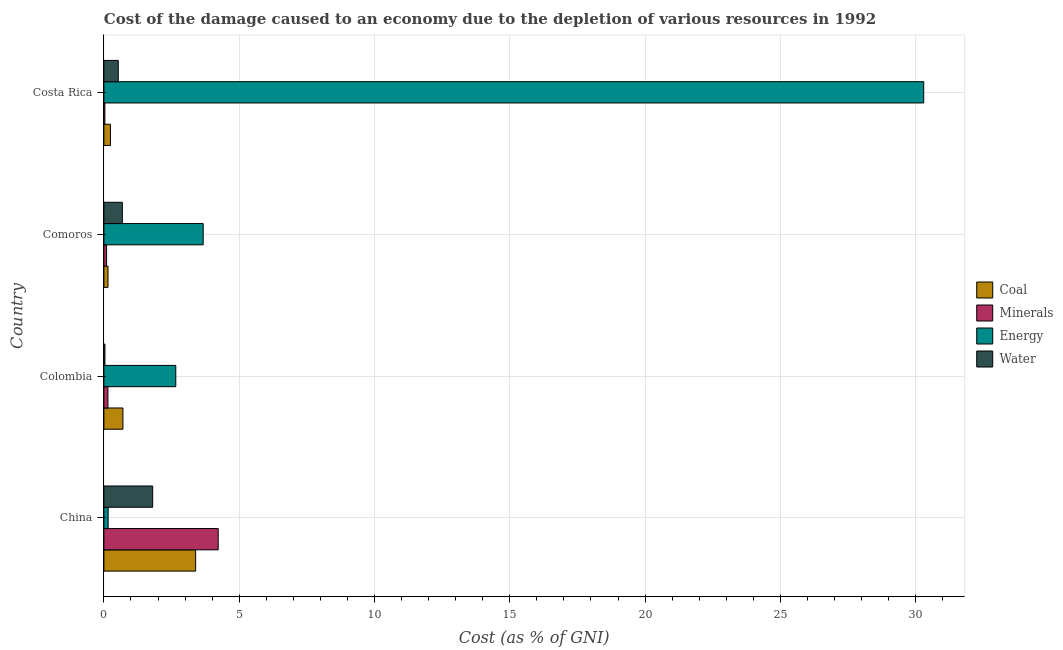How many different coloured bars are there?
Make the answer very short. 4. How many groups of bars are there?
Offer a very short reply. 4. Are the number of bars per tick equal to the number of legend labels?
Your response must be concise. Yes. What is the label of the 4th group of bars from the top?
Keep it short and to the point. China. What is the cost of damage due to depletion of coal in Colombia?
Your answer should be compact. 0.7. Across all countries, what is the maximum cost of damage due to depletion of coal?
Keep it short and to the point. 3.39. Across all countries, what is the minimum cost of damage due to depletion of energy?
Your answer should be very brief. 0.16. In which country was the cost of damage due to depletion of coal maximum?
Ensure brevity in your answer.  China. In which country was the cost of damage due to depletion of energy minimum?
Provide a short and direct response. China. What is the total cost of damage due to depletion of energy in the graph?
Your response must be concise. 36.78. What is the difference between the cost of damage due to depletion of coal in Comoros and that in Costa Rica?
Your answer should be compact. -0.09. What is the difference between the cost of damage due to depletion of water in Costa Rica and the cost of damage due to depletion of energy in Comoros?
Your answer should be very brief. -3.14. What is the average cost of damage due to depletion of coal per country?
Offer a terse response. 1.12. What is the difference between the cost of damage due to depletion of minerals and cost of damage due to depletion of energy in Costa Rica?
Your response must be concise. -30.26. In how many countries, is the cost of damage due to depletion of coal greater than 30 %?
Your answer should be very brief. 0. What is the ratio of the cost of damage due to depletion of energy in Comoros to that in Costa Rica?
Keep it short and to the point. 0.12. What is the difference between the highest and the second highest cost of damage due to depletion of water?
Offer a very short reply. 1.12. What is the difference between the highest and the lowest cost of damage due to depletion of water?
Your answer should be very brief. 1.76. In how many countries, is the cost of damage due to depletion of minerals greater than the average cost of damage due to depletion of minerals taken over all countries?
Provide a succinct answer. 1. Is the sum of the cost of damage due to depletion of coal in China and Colombia greater than the maximum cost of damage due to depletion of minerals across all countries?
Provide a succinct answer. No. What does the 4th bar from the top in Costa Rica represents?
Offer a terse response. Coal. What does the 2nd bar from the bottom in Colombia represents?
Keep it short and to the point. Minerals. Are all the bars in the graph horizontal?
Give a very brief answer. Yes. What is the difference between two consecutive major ticks on the X-axis?
Your answer should be very brief. 5. Does the graph contain any zero values?
Give a very brief answer. No. Where does the legend appear in the graph?
Your response must be concise. Center right. How are the legend labels stacked?
Provide a short and direct response. Vertical. What is the title of the graph?
Ensure brevity in your answer.  Cost of the damage caused to an economy due to the depletion of various resources in 1992 . Does "Greece" appear as one of the legend labels in the graph?
Your response must be concise. No. What is the label or title of the X-axis?
Provide a succinct answer. Cost (as % of GNI). What is the Cost (as % of GNI) of Coal in China?
Your answer should be very brief. 3.39. What is the Cost (as % of GNI) in Minerals in China?
Offer a terse response. 4.22. What is the Cost (as % of GNI) of Energy in China?
Give a very brief answer. 0.16. What is the Cost (as % of GNI) of Water in China?
Your response must be concise. 1.8. What is the Cost (as % of GNI) in Coal in Colombia?
Provide a short and direct response. 0.7. What is the Cost (as % of GNI) of Minerals in Colombia?
Keep it short and to the point. 0.15. What is the Cost (as % of GNI) in Energy in Colombia?
Give a very brief answer. 2.66. What is the Cost (as % of GNI) of Water in Colombia?
Provide a succinct answer. 0.04. What is the Cost (as % of GNI) of Coal in Comoros?
Offer a terse response. 0.15. What is the Cost (as % of GNI) of Minerals in Comoros?
Offer a very short reply. 0.1. What is the Cost (as % of GNI) of Energy in Comoros?
Your answer should be compact. 3.67. What is the Cost (as % of GNI) of Water in Comoros?
Provide a succinct answer. 0.68. What is the Cost (as % of GNI) of Coal in Costa Rica?
Offer a terse response. 0.24. What is the Cost (as % of GNI) of Minerals in Costa Rica?
Provide a succinct answer. 0.04. What is the Cost (as % of GNI) in Energy in Costa Rica?
Your answer should be compact. 30.3. What is the Cost (as % of GNI) of Water in Costa Rica?
Your answer should be very brief. 0.53. Across all countries, what is the maximum Cost (as % of GNI) in Coal?
Offer a very short reply. 3.39. Across all countries, what is the maximum Cost (as % of GNI) of Minerals?
Offer a very short reply. 4.22. Across all countries, what is the maximum Cost (as % of GNI) in Energy?
Your response must be concise. 30.3. Across all countries, what is the maximum Cost (as % of GNI) in Water?
Your response must be concise. 1.8. Across all countries, what is the minimum Cost (as % of GNI) in Coal?
Ensure brevity in your answer.  0.15. Across all countries, what is the minimum Cost (as % of GNI) in Minerals?
Your response must be concise. 0.04. Across all countries, what is the minimum Cost (as % of GNI) of Energy?
Offer a very short reply. 0.16. Across all countries, what is the minimum Cost (as % of GNI) in Water?
Your answer should be very brief. 0.04. What is the total Cost (as % of GNI) in Coal in the graph?
Make the answer very short. 4.49. What is the total Cost (as % of GNI) in Minerals in the graph?
Make the answer very short. 4.51. What is the total Cost (as % of GNI) in Energy in the graph?
Offer a very short reply. 36.78. What is the total Cost (as % of GNI) of Water in the graph?
Make the answer very short. 3.06. What is the difference between the Cost (as % of GNI) of Coal in China and that in Colombia?
Ensure brevity in your answer.  2.69. What is the difference between the Cost (as % of GNI) in Minerals in China and that in Colombia?
Your answer should be very brief. 4.08. What is the difference between the Cost (as % of GNI) in Energy in China and that in Colombia?
Provide a succinct answer. -2.5. What is the difference between the Cost (as % of GNI) in Water in China and that in Colombia?
Offer a very short reply. 1.76. What is the difference between the Cost (as % of GNI) of Coal in China and that in Comoros?
Your response must be concise. 3.24. What is the difference between the Cost (as % of GNI) of Minerals in China and that in Comoros?
Make the answer very short. 4.13. What is the difference between the Cost (as % of GNI) of Energy in China and that in Comoros?
Ensure brevity in your answer.  -3.51. What is the difference between the Cost (as % of GNI) of Water in China and that in Comoros?
Keep it short and to the point. 1.12. What is the difference between the Cost (as % of GNI) in Coal in China and that in Costa Rica?
Ensure brevity in your answer.  3.15. What is the difference between the Cost (as % of GNI) of Minerals in China and that in Costa Rica?
Provide a succinct answer. 4.19. What is the difference between the Cost (as % of GNI) in Energy in China and that in Costa Rica?
Make the answer very short. -30.14. What is the difference between the Cost (as % of GNI) in Water in China and that in Costa Rica?
Your answer should be very brief. 1.27. What is the difference between the Cost (as % of GNI) in Coal in Colombia and that in Comoros?
Your answer should be compact. 0.55. What is the difference between the Cost (as % of GNI) in Minerals in Colombia and that in Comoros?
Ensure brevity in your answer.  0.05. What is the difference between the Cost (as % of GNI) of Energy in Colombia and that in Comoros?
Keep it short and to the point. -1.01. What is the difference between the Cost (as % of GNI) in Water in Colombia and that in Comoros?
Provide a short and direct response. -0.64. What is the difference between the Cost (as % of GNI) in Coal in Colombia and that in Costa Rica?
Offer a very short reply. 0.46. What is the difference between the Cost (as % of GNI) of Minerals in Colombia and that in Costa Rica?
Provide a short and direct response. 0.11. What is the difference between the Cost (as % of GNI) in Energy in Colombia and that in Costa Rica?
Your response must be concise. -27.64. What is the difference between the Cost (as % of GNI) of Water in Colombia and that in Costa Rica?
Offer a terse response. -0.49. What is the difference between the Cost (as % of GNI) in Coal in Comoros and that in Costa Rica?
Offer a very short reply. -0.09. What is the difference between the Cost (as % of GNI) of Minerals in Comoros and that in Costa Rica?
Your response must be concise. 0.06. What is the difference between the Cost (as % of GNI) in Energy in Comoros and that in Costa Rica?
Offer a terse response. -26.63. What is the difference between the Cost (as % of GNI) in Water in Comoros and that in Costa Rica?
Provide a short and direct response. 0.15. What is the difference between the Cost (as % of GNI) of Coal in China and the Cost (as % of GNI) of Minerals in Colombia?
Provide a succinct answer. 3.24. What is the difference between the Cost (as % of GNI) of Coal in China and the Cost (as % of GNI) of Energy in Colombia?
Offer a very short reply. 0.73. What is the difference between the Cost (as % of GNI) in Coal in China and the Cost (as % of GNI) in Water in Colombia?
Your answer should be very brief. 3.35. What is the difference between the Cost (as % of GNI) of Minerals in China and the Cost (as % of GNI) of Energy in Colombia?
Offer a terse response. 1.57. What is the difference between the Cost (as % of GNI) in Minerals in China and the Cost (as % of GNI) in Water in Colombia?
Ensure brevity in your answer.  4.19. What is the difference between the Cost (as % of GNI) in Energy in China and the Cost (as % of GNI) in Water in Colombia?
Your answer should be compact. 0.12. What is the difference between the Cost (as % of GNI) in Coal in China and the Cost (as % of GNI) in Minerals in Comoros?
Offer a very short reply. 3.29. What is the difference between the Cost (as % of GNI) of Coal in China and the Cost (as % of GNI) of Energy in Comoros?
Your answer should be compact. -0.28. What is the difference between the Cost (as % of GNI) of Coal in China and the Cost (as % of GNI) of Water in Comoros?
Keep it short and to the point. 2.71. What is the difference between the Cost (as % of GNI) of Minerals in China and the Cost (as % of GNI) of Energy in Comoros?
Your response must be concise. 0.55. What is the difference between the Cost (as % of GNI) of Minerals in China and the Cost (as % of GNI) of Water in Comoros?
Provide a short and direct response. 3.54. What is the difference between the Cost (as % of GNI) in Energy in China and the Cost (as % of GNI) in Water in Comoros?
Provide a succinct answer. -0.52. What is the difference between the Cost (as % of GNI) in Coal in China and the Cost (as % of GNI) in Minerals in Costa Rica?
Your answer should be very brief. 3.35. What is the difference between the Cost (as % of GNI) of Coal in China and the Cost (as % of GNI) of Energy in Costa Rica?
Ensure brevity in your answer.  -26.91. What is the difference between the Cost (as % of GNI) in Coal in China and the Cost (as % of GNI) in Water in Costa Rica?
Make the answer very short. 2.86. What is the difference between the Cost (as % of GNI) in Minerals in China and the Cost (as % of GNI) in Energy in Costa Rica?
Your answer should be very brief. -26.07. What is the difference between the Cost (as % of GNI) in Minerals in China and the Cost (as % of GNI) in Water in Costa Rica?
Your response must be concise. 3.69. What is the difference between the Cost (as % of GNI) in Energy in China and the Cost (as % of GNI) in Water in Costa Rica?
Provide a succinct answer. -0.38. What is the difference between the Cost (as % of GNI) of Coal in Colombia and the Cost (as % of GNI) of Minerals in Comoros?
Your answer should be compact. 0.6. What is the difference between the Cost (as % of GNI) in Coal in Colombia and the Cost (as % of GNI) in Energy in Comoros?
Ensure brevity in your answer.  -2.97. What is the difference between the Cost (as % of GNI) of Coal in Colombia and the Cost (as % of GNI) of Water in Comoros?
Your response must be concise. 0.02. What is the difference between the Cost (as % of GNI) in Minerals in Colombia and the Cost (as % of GNI) in Energy in Comoros?
Keep it short and to the point. -3.52. What is the difference between the Cost (as % of GNI) in Minerals in Colombia and the Cost (as % of GNI) in Water in Comoros?
Your answer should be very brief. -0.53. What is the difference between the Cost (as % of GNI) of Energy in Colombia and the Cost (as % of GNI) of Water in Comoros?
Ensure brevity in your answer.  1.98. What is the difference between the Cost (as % of GNI) of Coal in Colombia and the Cost (as % of GNI) of Minerals in Costa Rica?
Your response must be concise. 0.67. What is the difference between the Cost (as % of GNI) of Coal in Colombia and the Cost (as % of GNI) of Energy in Costa Rica?
Provide a succinct answer. -29.6. What is the difference between the Cost (as % of GNI) in Coal in Colombia and the Cost (as % of GNI) in Water in Costa Rica?
Ensure brevity in your answer.  0.17. What is the difference between the Cost (as % of GNI) of Minerals in Colombia and the Cost (as % of GNI) of Energy in Costa Rica?
Provide a short and direct response. -30.15. What is the difference between the Cost (as % of GNI) of Minerals in Colombia and the Cost (as % of GNI) of Water in Costa Rica?
Offer a terse response. -0.38. What is the difference between the Cost (as % of GNI) in Energy in Colombia and the Cost (as % of GNI) in Water in Costa Rica?
Your answer should be compact. 2.12. What is the difference between the Cost (as % of GNI) of Coal in Comoros and the Cost (as % of GNI) of Minerals in Costa Rica?
Ensure brevity in your answer.  0.12. What is the difference between the Cost (as % of GNI) in Coal in Comoros and the Cost (as % of GNI) in Energy in Costa Rica?
Give a very brief answer. -30.15. What is the difference between the Cost (as % of GNI) of Coal in Comoros and the Cost (as % of GNI) of Water in Costa Rica?
Keep it short and to the point. -0.38. What is the difference between the Cost (as % of GNI) of Minerals in Comoros and the Cost (as % of GNI) of Energy in Costa Rica?
Your response must be concise. -30.2. What is the difference between the Cost (as % of GNI) in Minerals in Comoros and the Cost (as % of GNI) in Water in Costa Rica?
Your response must be concise. -0.43. What is the difference between the Cost (as % of GNI) in Energy in Comoros and the Cost (as % of GNI) in Water in Costa Rica?
Your response must be concise. 3.14. What is the average Cost (as % of GNI) of Coal per country?
Give a very brief answer. 1.12. What is the average Cost (as % of GNI) of Minerals per country?
Your answer should be very brief. 1.13. What is the average Cost (as % of GNI) of Energy per country?
Ensure brevity in your answer.  9.2. What is the average Cost (as % of GNI) of Water per country?
Give a very brief answer. 0.76. What is the difference between the Cost (as % of GNI) in Coal and Cost (as % of GNI) in Minerals in China?
Offer a terse response. -0.83. What is the difference between the Cost (as % of GNI) of Coal and Cost (as % of GNI) of Energy in China?
Your answer should be compact. 3.23. What is the difference between the Cost (as % of GNI) in Coal and Cost (as % of GNI) in Water in China?
Your answer should be compact. 1.59. What is the difference between the Cost (as % of GNI) of Minerals and Cost (as % of GNI) of Energy in China?
Offer a very short reply. 4.07. What is the difference between the Cost (as % of GNI) in Minerals and Cost (as % of GNI) in Water in China?
Keep it short and to the point. 2.42. What is the difference between the Cost (as % of GNI) of Energy and Cost (as % of GNI) of Water in China?
Your response must be concise. -1.65. What is the difference between the Cost (as % of GNI) of Coal and Cost (as % of GNI) of Minerals in Colombia?
Your answer should be compact. 0.55. What is the difference between the Cost (as % of GNI) of Coal and Cost (as % of GNI) of Energy in Colombia?
Your answer should be very brief. -1.95. What is the difference between the Cost (as % of GNI) in Coal and Cost (as % of GNI) in Water in Colombia?
Your answer should be very brief. 0.66. What is the difference between the Cost (as % of GNI) in Minerals and Cost (as % of GNI) in Energy in Colombia?
Keep it short and to the point. -2.51. What is the difference between the Cost (as % of GNI) of Minerals and Cost (as % of GNI) of Water in Colombia?
Provide a succinct answer. 0.11. What is the difference between the Cost (as % of GNI) in Energy and Cost (as % of GNI) in Water in Colombia?
Make the answer very short. 2.62. What is the difference between the Cost (as % of GNI) of Coal and Cost (as % of GNI) of Minerals in Comoros?
Ensure brevity in your answer.  0.05. What is the difference between the Cost (as % of GNI) in Coal and Cost (as % of GNI) in Energy in Comoros?
Provide a short and direct response. -3.52. What is the difference between the Cost (as % of GNI) in Coal and Cost (as % of GNI) in Water in Comoros?
Make the answer very short. -0.53. What is the difference between the Cost (as % of GNI) in Minerals and Cost (as % of GNI) in Energy in Comoros?
Provide a succinct answer. -3.57. What is the difference between the Cost (as % of GNI) of Minerals and Cost (as % of GNI) of Water in Comoros?
Provide a succinct answer. -0.58. What is the difference between the Cost (as % of GNI) of Energy and Cost (as % of GNI) of Water in Comoros?
Keep it short and to the point. 2.99. What is the difference between the Cost (as % of GNI) of Coal and Cost (as % of GNI) of Minerals in Costa Rica?
Offer a very short reply. 0.21. What is the difference between the Cost (as % of GNI) in Coal and Cost (as % of GNI) in Energy in Costa Rica?
Give a very brief answer. -30.06. What is the difference between the Cost (as % of GNI) in Coal and Cost (as % of GNI) in Water in Costa Rica?
Make the answer very short. -0.29. What is the difference between the Cost (as % of GNI) in Minerals and Cost (as % of GNI) in Energy in Costa Rica?
Make the answer very short. -30.26. What is the difference between the Cost (as % of GNI) of Minerals and Cost (as % of GNI) of Water in Costa Rica?
Provide a succinct answer. -0.5. What is the difference between the Cost (as % of GNI) of Energy and Cost (as % of GNI) of Water in Costa Rica?
Your answer should be very brief. 29.77. What is the ratio of the Cost (as % of GNI) of Coal in China to that in Colombia?
Your answer should be very brief. 4.83. What is the ratio of the Cost (as % of GNI) of Minerals in China to that in Colombia?
Keep it short and to the point. 28.32. What is the ratio of the Cost (as % of GNI) in Energy in China to that in Colombia?
Your response must be concise. 0.06. What is the ratio of the Cost (as % of GNI) of Water in China to that in Colombia?
Your answer should be very brief. 46.44. What is the ratio of the Cost (as % of GNI) in Coal in China to that in Comoros?
Ensure brevity in your answer.  22.24. What is the ratio of the Cost (as % of GNI) of Minerals in China to that in Comoros?
Provide a short and direct response. 42.84. What is the ratio of the Cost (as % of GNI) in Energy in China to that in Comoros?
Make the answer very short. 0.04. What is the ratio of the Cost (as % of GNI) in Water in China to that in Comoros?
Ensure brevity in your answer.  2.64. What is the ratio of the Cost (as % of GNI) in Coal in China to that in Costa Rica?
Make the answer very short. 13.98. What is the ratio of the Cost (as % of GNI) of Minerals in China to that in Costa Rica?
Ensure brevity in your answer.  116.24. What is the ratio of the Cost (as % of GNI) of Energy in China to that in Costa Rica?
Give a very brief answer. 0.01. What is the ratio of the Cost (as % of GNI) of Water in China to that in Costa Rica?
Provide a short and direct response. 3.39. What is the ratio of the Cost (as % of GNI) of Coal in Colombia to that in Comoros?
Your answer should be compact. 4.61. What is the ratio of the Cost (as % of GNI) of Minerals in Colombia to that in Comoros?
Offer a terse response. 1.51. What is the ratio of the Cost (as % of GNI) in Energy in Colombia to that in Comoros?
Offer a very short reply. 0.72. What is the ratio of the Cost (as % of GNI) of Water in Colombia to that in Comoros?
Keep it short and to the point. 0.06. What is the ratio of the Cost (as % of GNI) of Coal in Colombia to that in Costa Rica?
Keep it short and to the point. 2.9. What is the ratio of the Cost (as % of GNI) in Minerals in Colombia to that in Costa Rica?
Ensure brevity in your answer.  4.1. What is the ratio of the Cost (as % of GNI) of Energy in Colombia to that in Costa Rica?
Give a very brief answer. 0.09. What is the ratio of the Cost (as % of GNI) of Water in Colombia to that in Costa Rica?
Provide a short and direct response. 0.07. What is the ratio of the Cost (as % of GNI) in Coal in Comoros to that in Costa Rica?
Offer a very short reply. 0.63. What is the ratio of the Cost (as % of GNI) in Minerals in Comoros to that in Costa Rica?
Your response must be concise. 2.71. What is the ratio of the Cost (as % of GNI) of Energy in Comoros to that in Costa Rica?
Your response must be concise. 0.12. What is the ratio of the Cost (as % of GNI) in Water in Comoros to that in Costa Rica?
Keep it short and to the point. 1.28. What is the difference between the highest and the second highest Cost (as % of GNI) of Coal?
Offer a terse response. 2.69. What is the difference between the highest and the second highest Cost (as % of GNI) of Minerals?
Your answer should be compact. 4.08. What is the difference between the highest and the second highest Cost (as % of GNI) of Energy?
Give a very brief answer. 26.63. What is the difference between the highest and the second highest Cost (as % of GNI) in Water?
Offer a very short reply. 1.12. What is the difference between the highest and the lowest Cost (as % of GNI) in Coal?
Your answer should be compact. 3.24. What is the difference between the highest and the lowest Cost (as % of GNI) of Minerals?
Offer a terse response. 4.19. What is the difference between the highest and the lowest Cost (as % of GNI) in Energy?
Provide a short and direct response. 30.14. What is the difference between the highest and the lowest Cost (as % of GNI) of Water?
Make the answer very short. 1.76. 